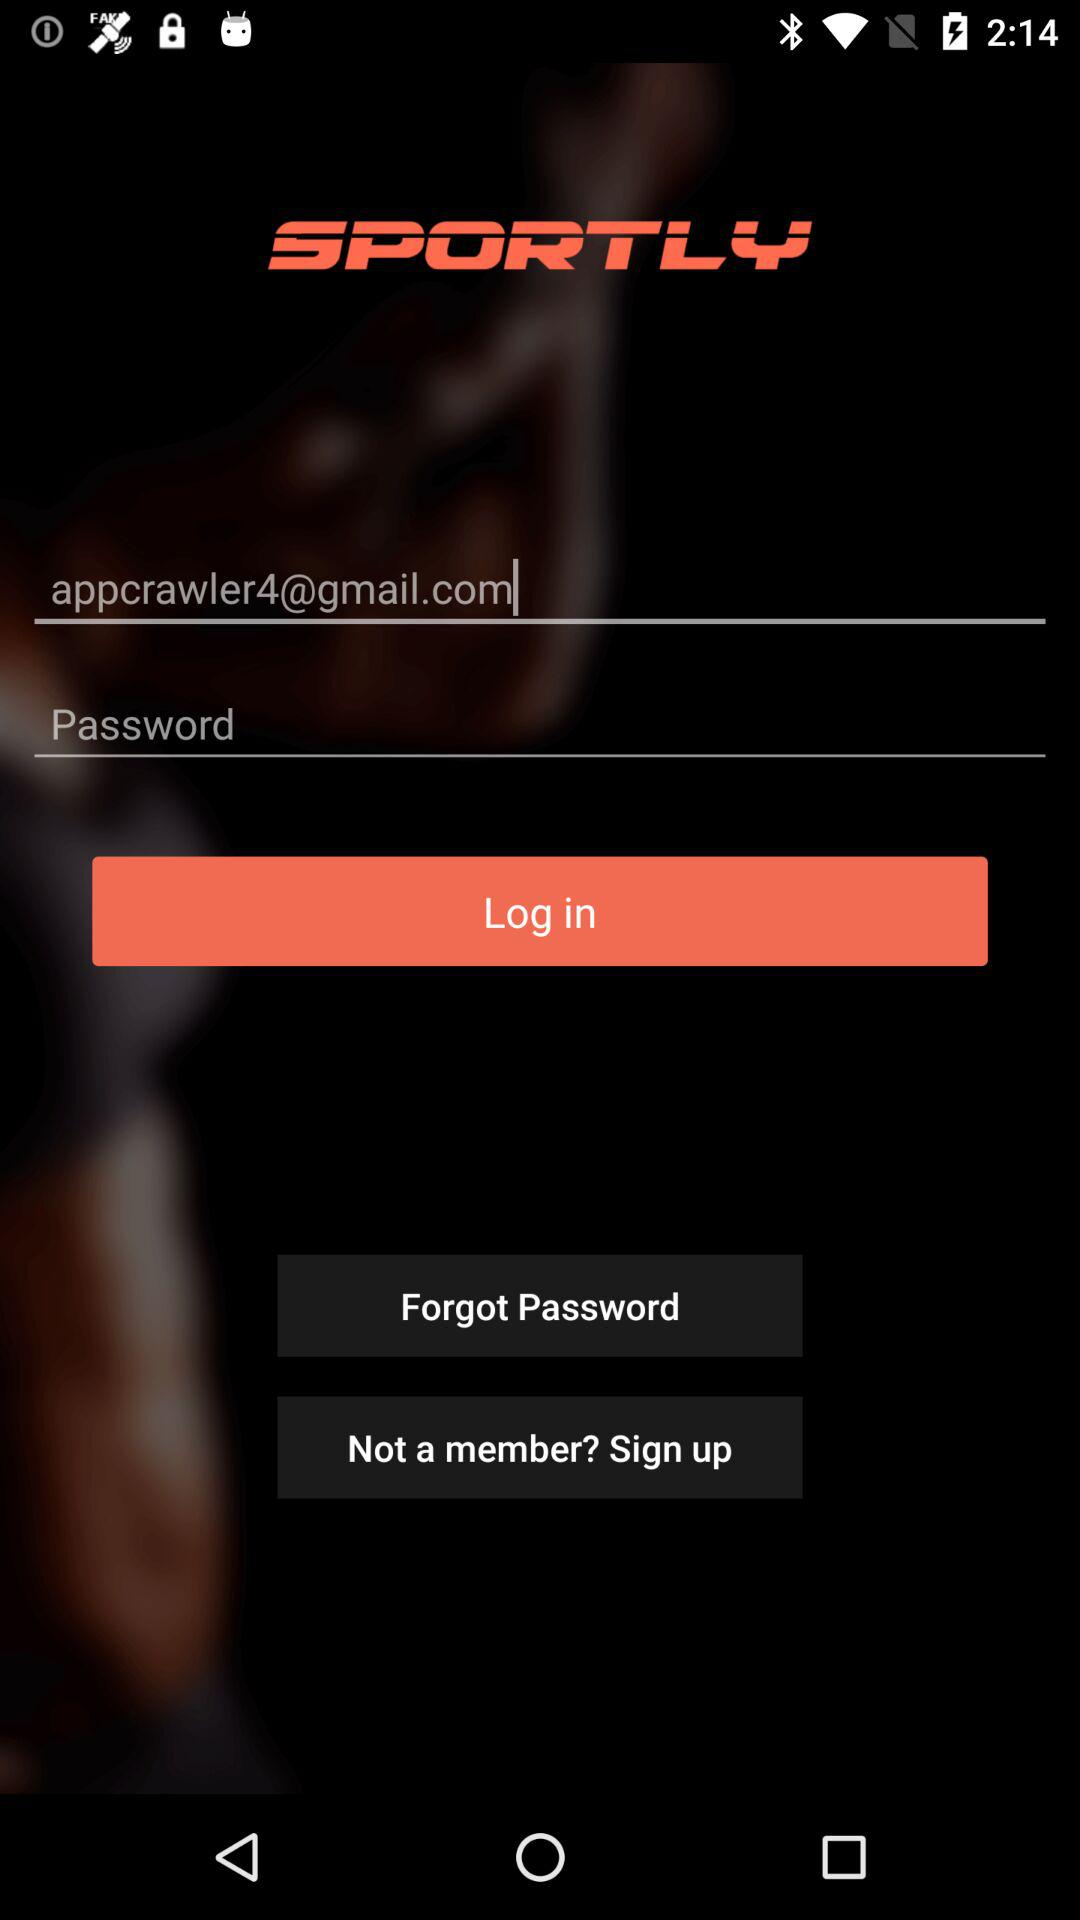What is the email address? The email address is appcrawler4@gmail.com. 